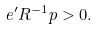Convert formula to latex. <formula><loc_0><loc_0><loc_500><loc_500>e ^ { \prime } R ^ { - 1 } p > 0 .</formula> 